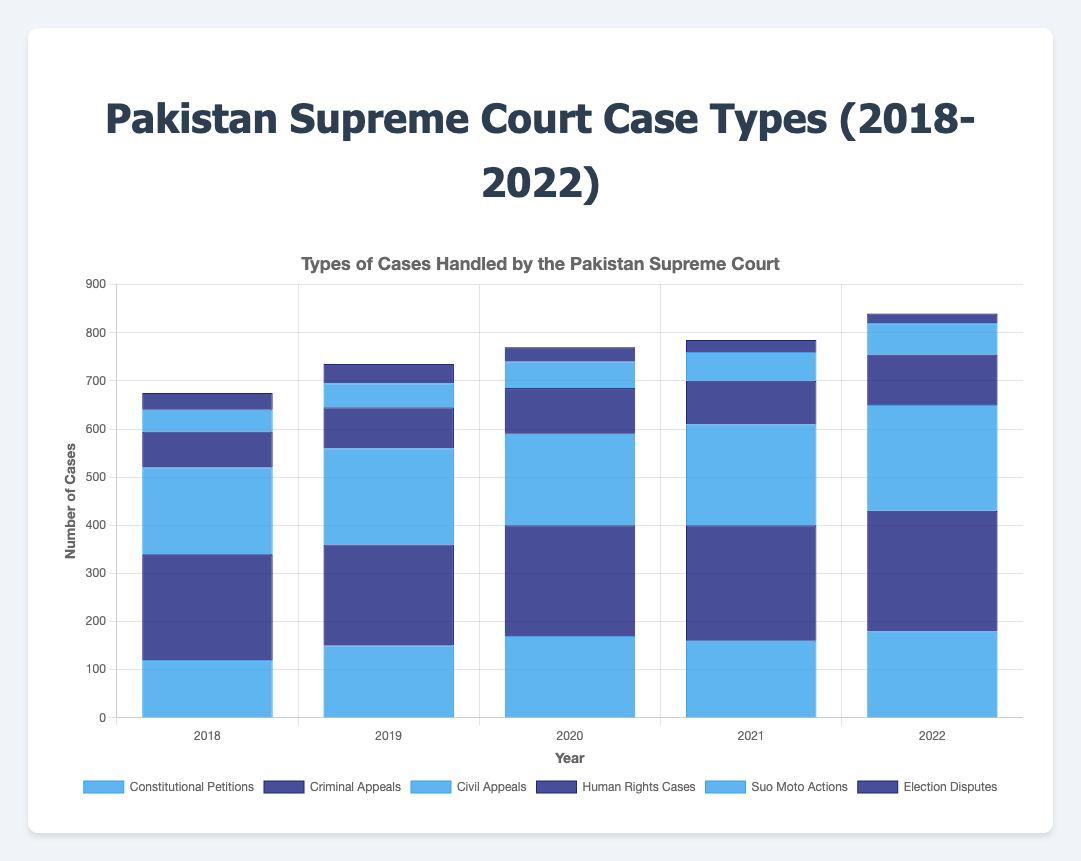What is the trend of Constitutional Petitions from 2018 to 2022? To see the trend, look at the bars representing Constitutional Petitions from 2018 to 2022. In 2018, there were 120 cases. This number increased to 150 in 2019 and 170 in 2020. It slightly decreased to 160 in 2021 but rose again to 180 in 2022. The overall trend is an increase in cases.
Answer: Increasing How do Criminal Appeals compare to Civil Appeals in 2020? Look at the heights of the bars for Criminal Appeals and Civil Appeals in 2020. Criminal Appeals had 230 cases, while Civil Appeals had 190 cases. Comparing these numbers, Criminal Appeals had more cases than Civil Appeals.
Answer: Criminal Appeals had more cases Which type of cases had the highest number in any given year? Among all types of cases for all years, identify the highest bar. The highest number is for Criminal Appeals in 2022 with 250 cases.
Answer: Criminal Appeals in 2022 What is the total number of Human Rights Cases between 2018 and 2022? Add the number of Human Rights Cases from 2018 to 2022: 75 (2018) + 85 (2019) + 95 (2020) + 90 (2021) + 105 (2022). This sums to a total of 450.
Answer: 450 Which year saw the least number of Election Disputes, and how many were there? By comparing the height of the bars for Election Disputes across all years, 2022 has the shortest bar, representing the least number of cases, with 20 cases.
Answer: 2022 with 20 cases Compare the total number of Suo Moto Actions and Constitutional Petitions in 2019. Which is higher? Sum the number of cases for Suo Moto Actions and Constitutional Petitions in 2019. Suo Moto Actions had 50 cases and Constitutional Petitions had 150 cases. Therefore, Constitutional Petitions had a higher number of cases.
Answer: Constitutional Petitions What is the average number of Civil Appeals cases from 2018 to 2022? Calculate the average by adding the number of Civil Appeals cases for each year and then dividing by the number of years: (180 + 200 + 190 + 210 + 220) / 5 = 200.
Answer: 200 Which type of case had the most consistent (least fluctuating) number of cases from 2018 to 2022? Compare the fluctuations in the number of cases for all types of cases. Criminal Appeals had relatively steady numbers with cases ranging from 210 to 250, showing the least fluctuation compared to other case types.
Answer: Criminal Appeals In which year did the total number of cases for all types peak? Add up the number of cases for all types each year and find the highest total. The totals are as follows:
- 2018: 675
- 2019: 735
- 2020: 770
- 2021: 785
- 2022: 840
The peak is in 2022 with 840 cases.
Answer: 2022 Which two types of cases had the most significant difference in the number of cases in 2021, and what was the difference? Identify the two types of cases with the largest difference in 2021. The most significant difference is between Criminal Appeals (240) and Election Disputes (25). The difference is 240 - 25 = 215 cases.
Answer: Criminal Appeals and Election Disputes, 215 cases 